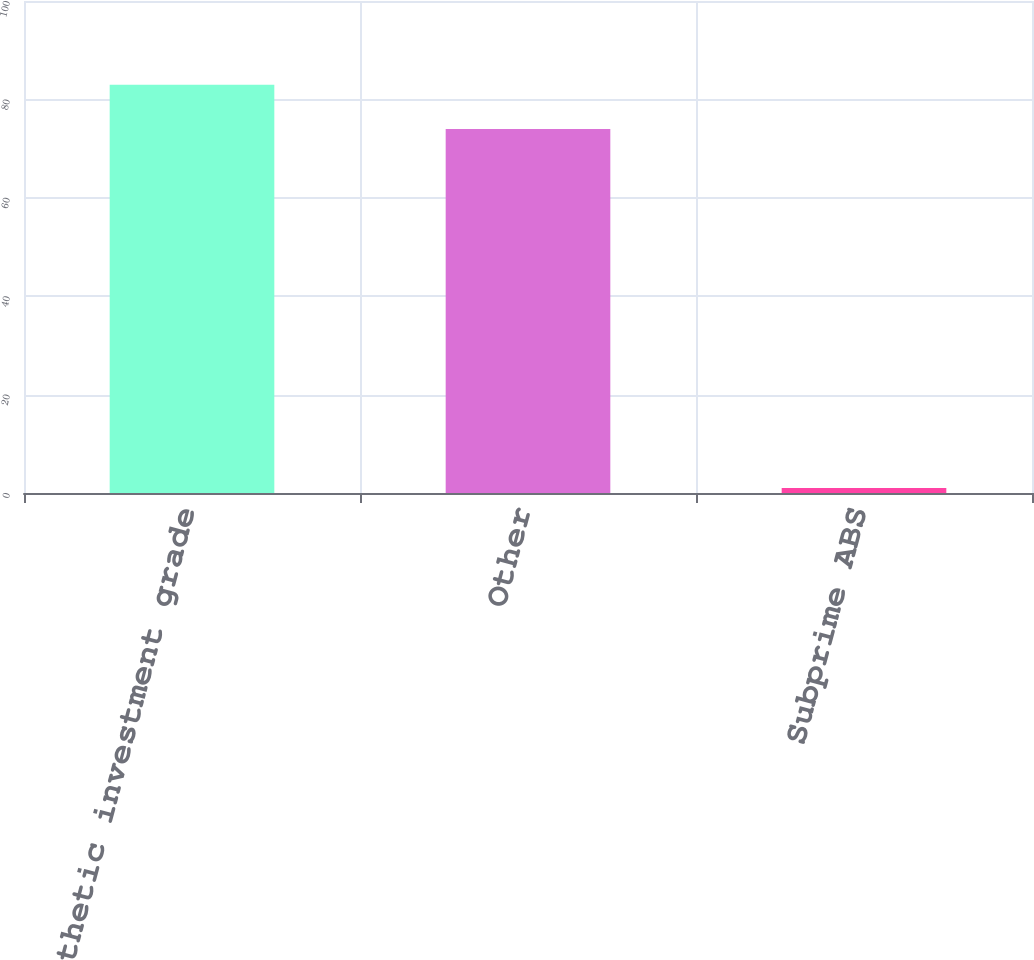<chart> <loc_0><loc_0><loc_500><loc_500><bar_chart><fcel>Synthetic investment grade<fcel>Other<fcel>Subprime ABS<nl><fcel>83<fcel>74<fcel>1<nl></chart> 